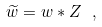<formula> <loc_0><loc_0><loc_500><loc_500>\widetilde { w } = w * Z \ ,</formula> 